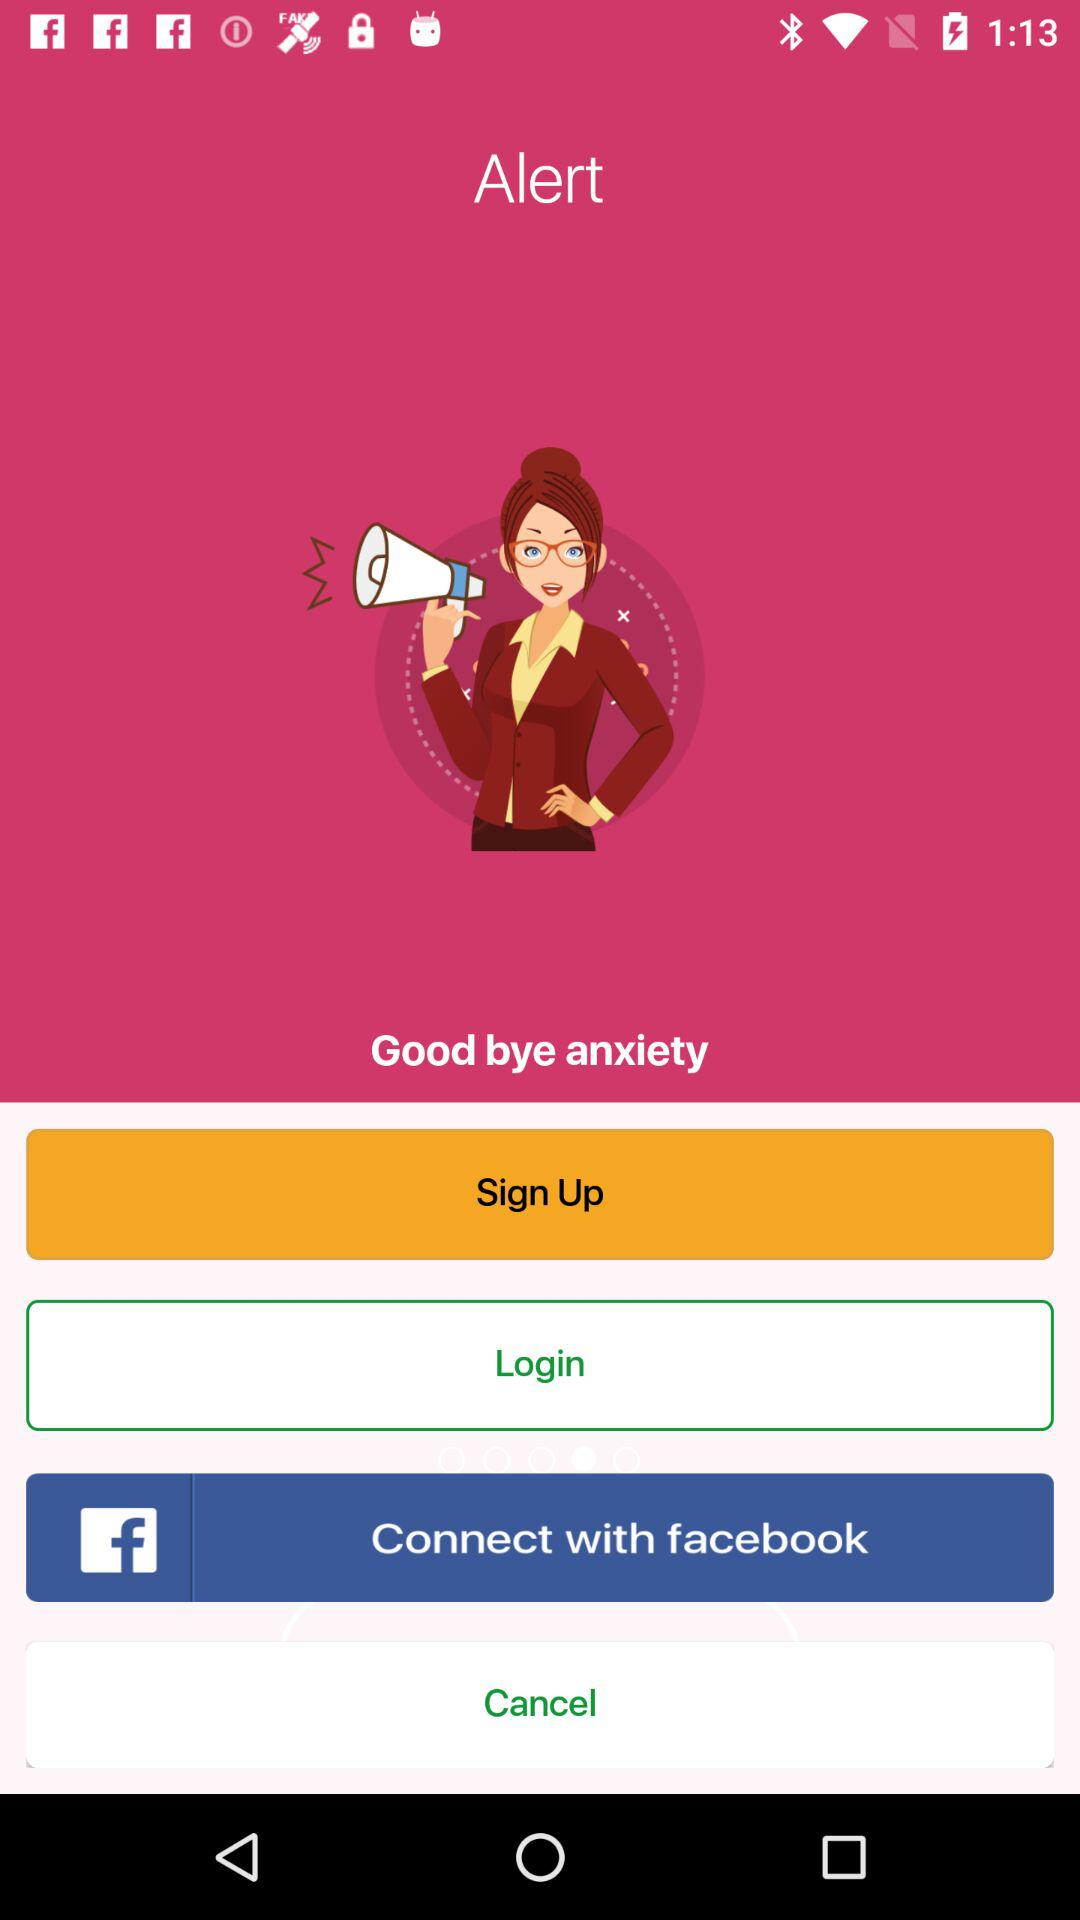What application can be used to connect? The application that can be used to connect is "facebook". 